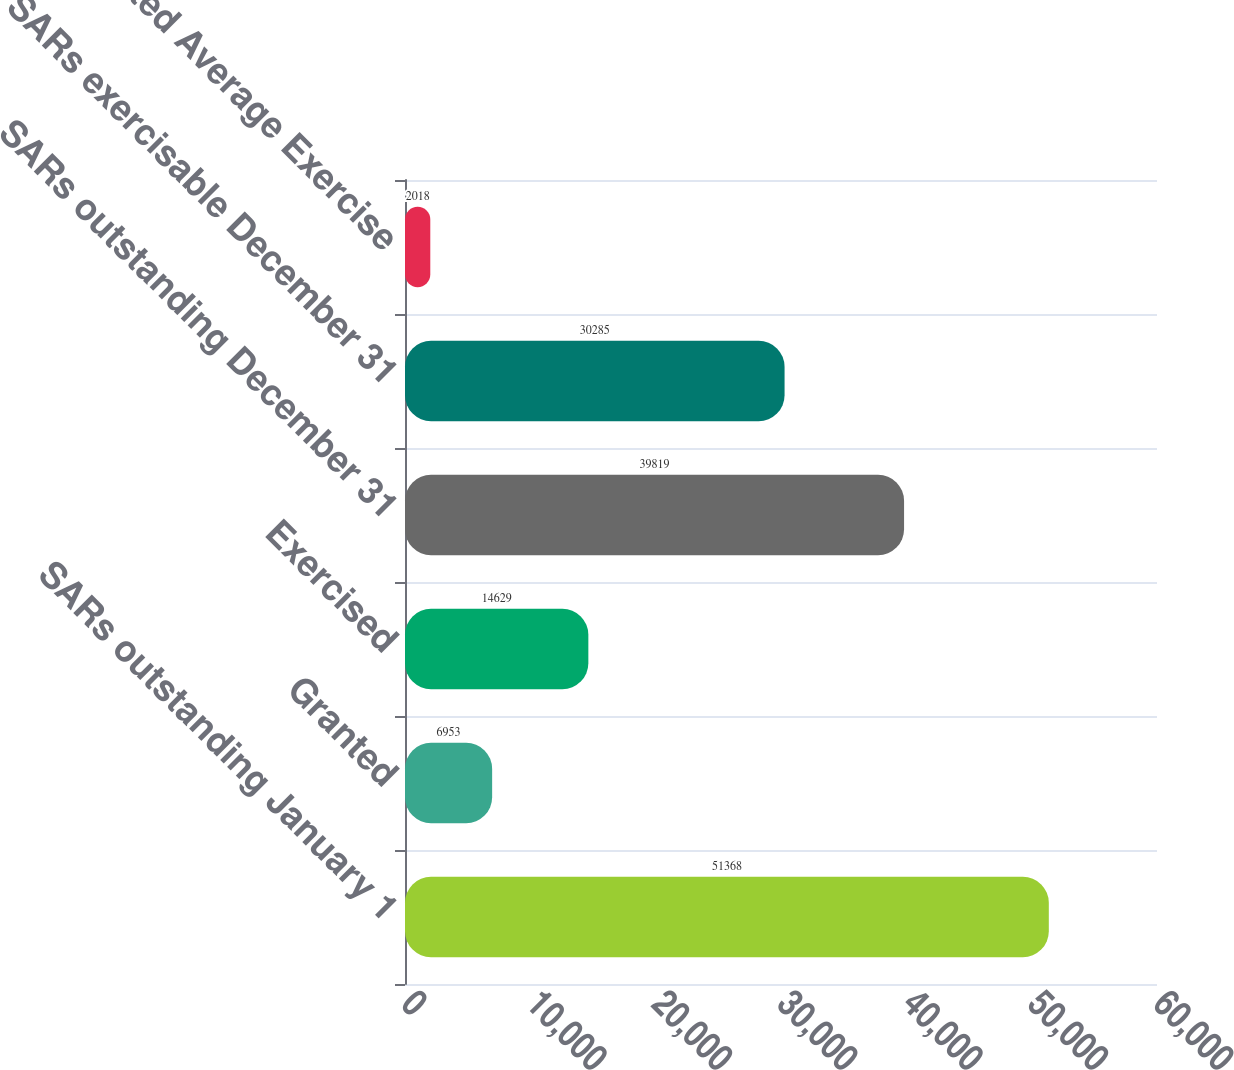<chart> <loc_0><loc_0><loc_500><loc_500><bar_chart><fcel>SARs outstanding January 1<fcel>Granted<fcel>Exercised<fcel>SARs outstanding December 31<fcel>SARs exercisable December 31<fcel>Weighted Average Exercise<nl><fcel>51368<fcel>6953<fcel>14629<fcel>39819<fcel>30285<fcel>2018<nl></chart> 